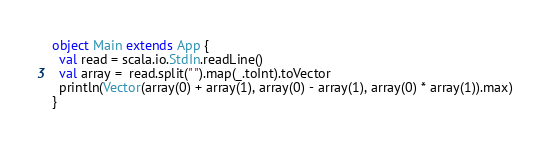<code> <loc_0><loc_0><loc_500><loc_500><_Scala_>object Main extends App {
  val read = scala.io.StdIn.readLine()
  val array =  read.split(" ").map(_.toInt).toVector
  println(Vector(array(0) + array(1), array(0) - array(1), array(0) * array(1)).max)
}</code> 